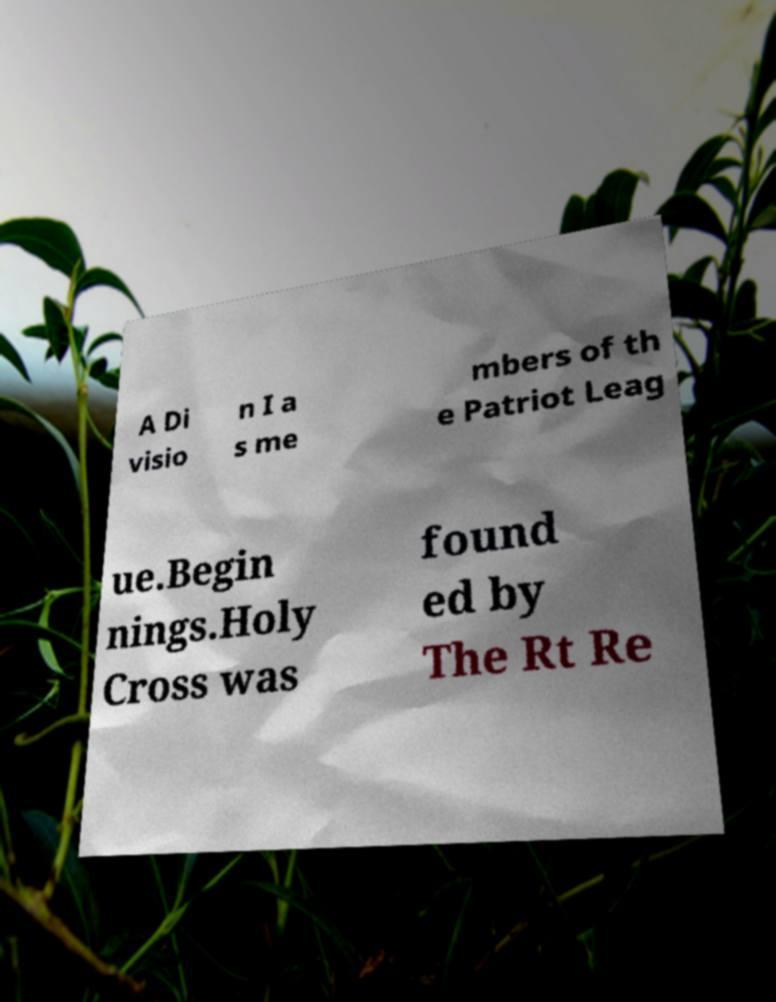Please identify and transcribe the text found in this image. A Di visio n I a s me mbers of th e Patriot Leag ue.Begin nings.Holy Cross was found ed by The Rt Re 